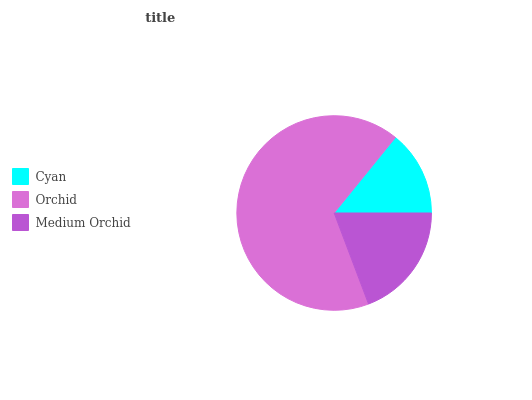Is Cyan the minimum?
Answer yes or no. Yes. Is Orchid the maximum?
Answer yes or no. Yes. Is Medium Orchid the minimum?
Answer yes or no. No. Is Medium Orchid the maximum?
Answer yes or no. No. Is Orchid greater than Medium Orchid?
Answer yes or no. Yes. Is Medium Orchid less than Orchid?
Answer yes or no. Yes. Is Medium Orchid greater than Orchid?
Answer yes or no. No. Is Orchid less than Medium Orchid?
Answer yes or no. No. Is Medium Orchid the high median?
Answer yes or no. Yes. Is Medium Orchid the low median?
Answer yes or no. Yes. Is Orchid the high median?
Answer yes or no. No. Is Orchid the low median?
Answer yes or no. No. 